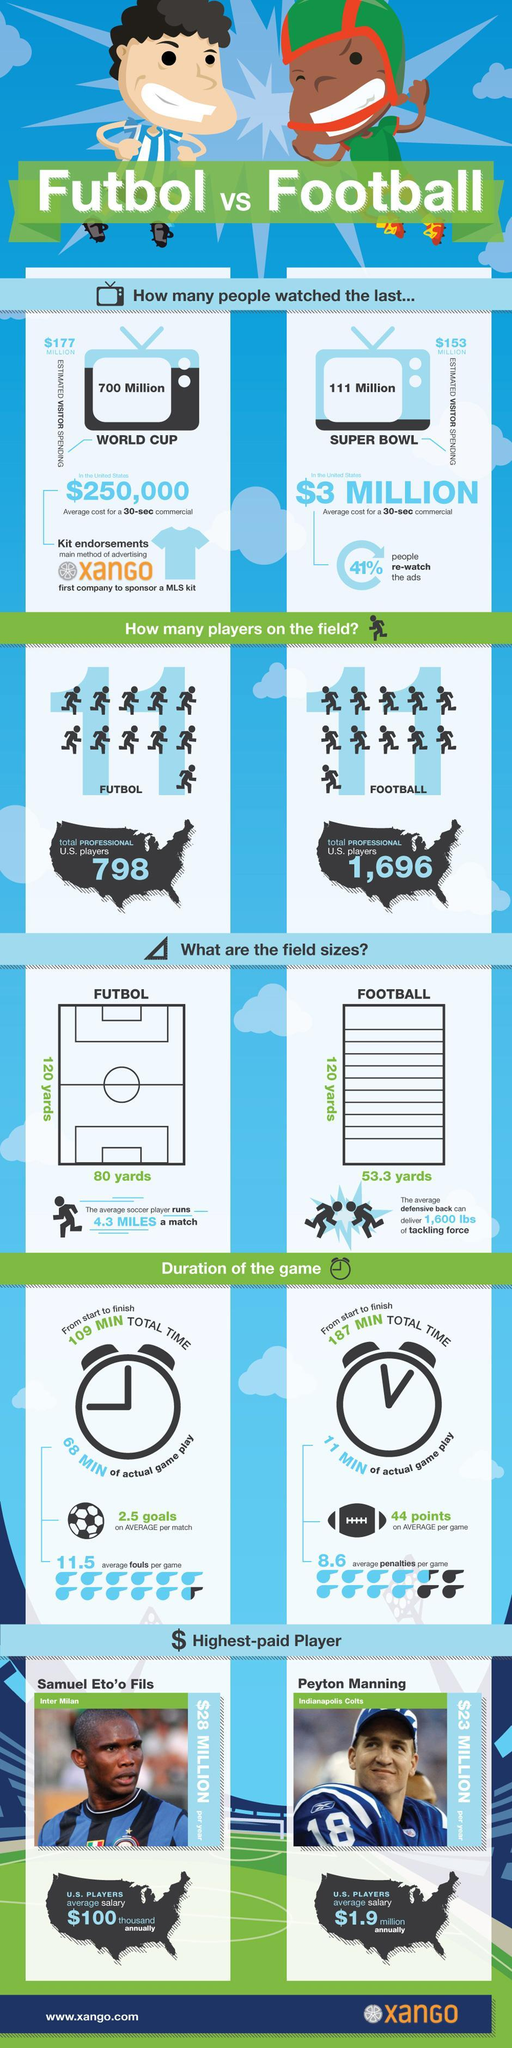How many more viewers did the World Cup have in comparison to the Super Bowl?
Answer the question with a short phrase. 619 Million What is the total duration of a Futbol game, 109 min, 187 min, or 68 min? 109 min What is the jersey number of Peyton Manning? 18 What is the breadth of the football field,120 yards, 80 yards, or 53.3 yards? 53.3 yards What is the number of players on field for Futbol and Football? 11 What is the length of the Futbol and Football fields? 120 yards Who is the highest paid futbol player, Samuel Eto'o Fils or Peyton Manning? Samuel Eto'o Fils 